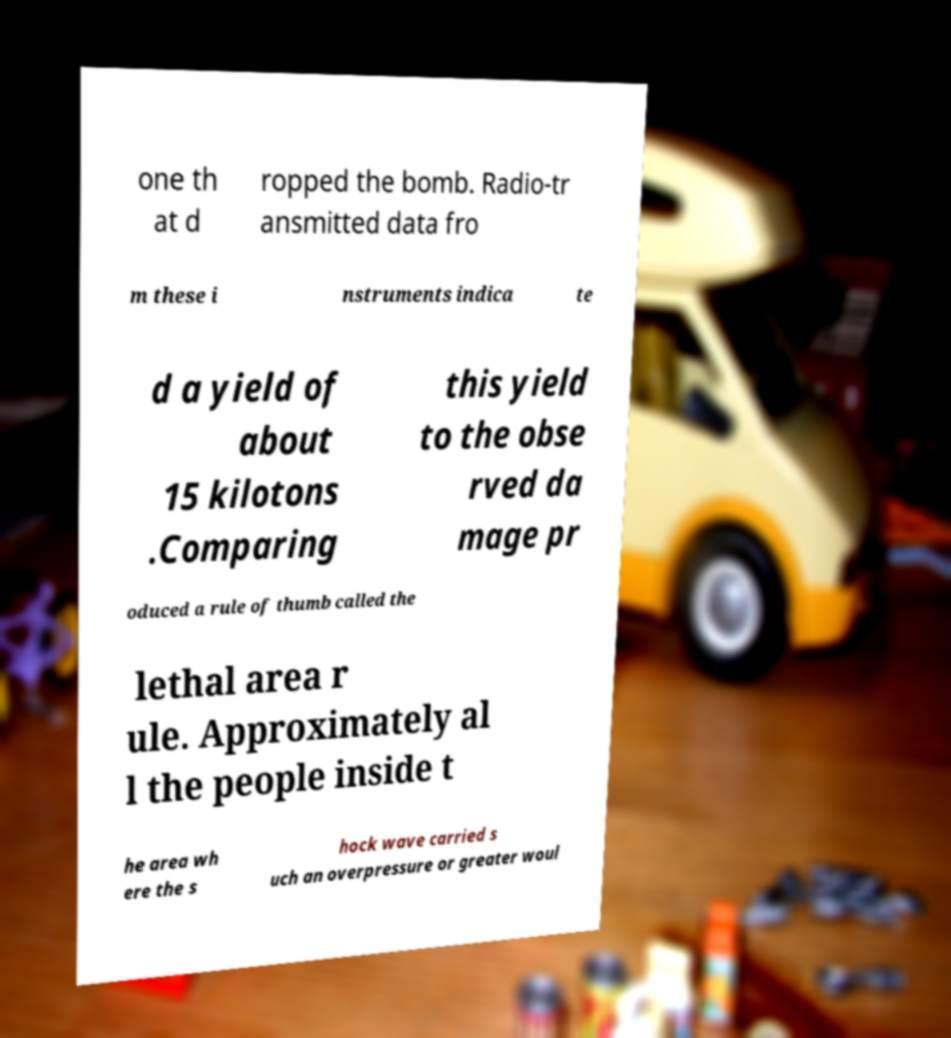Can you read and provide the text displayed in the image?This photo seems to have some interesting text. Can you extract and type it out for me? one th at d ropped the bomb. Radio-tr ansmitted data fro m these i nstruments indica te d a yield of about 15 kilotons .Comparing this yield to the obse rved da mage pr oduced a rule of thumb called the lethal area r ule. Approximately al l the people inside t he area wh ere the s hock wave carried s uch an overpressure or greater woul 